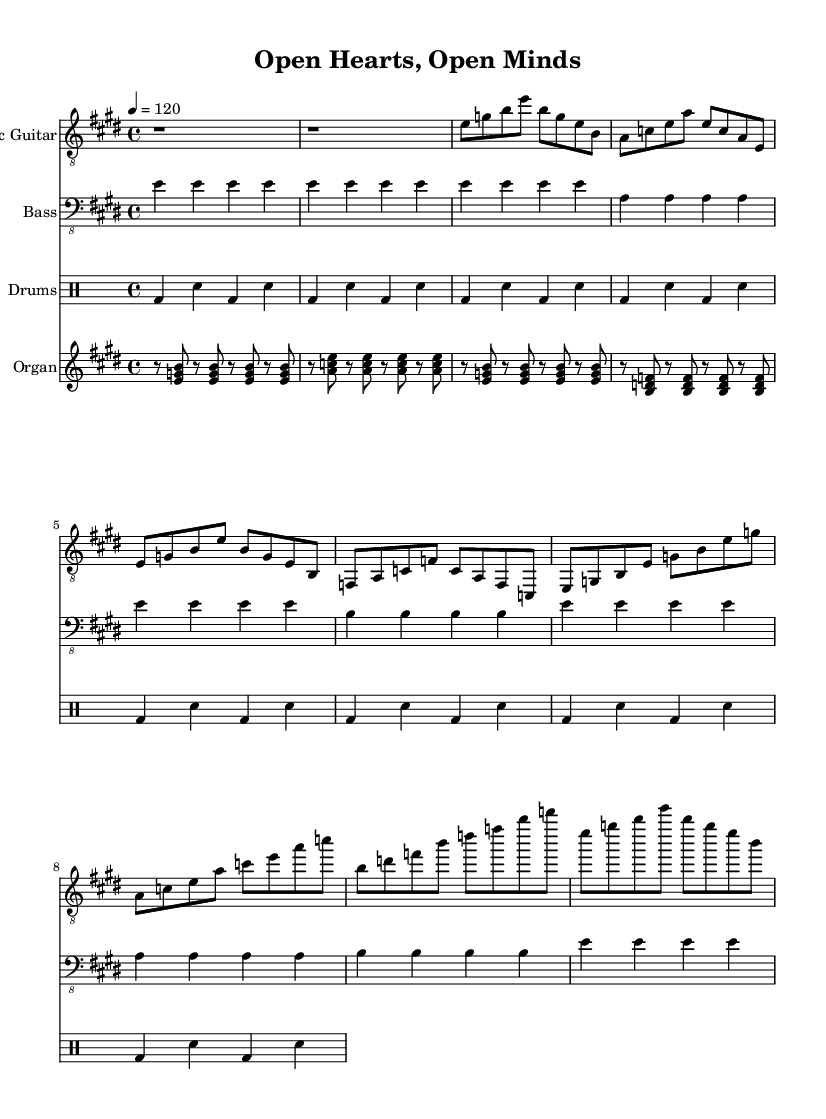What is the key signature of this piece? The key signature indicates the presence of four sharps, corresponding to E major.
Answer: E major What is the time signature of the music? The time signature shown in the music is 4/4, which means there are four beats in a measure and a quarter note gets one beat.
Answer: 4/4 What is the tempo marking for this composition? The tempo marking is indicated as "4 = 120," meaning there are 120 beats per minute, with each beat represented by a quarter note.
Answer: 120 How many measures are in the verse section? By analyzing the verse notation, there are four measures present. Each line of the verse consists of one measure, and there are four lines total.
Answer: 4 What type of instrument is providing the percussion part? The drumming part is clearly designated in a separate section labeled as "Drums," indicating that a drum kit is being used for the percussion.
Answer: Drums What distinctive feature does the organ part exhibit in terms of note placement? The organ part emphasizes offbeat chord stabs, which are consistently played on the eighth notes, creating a lively texture in the piece.
Answer: Offbeat chord stabs What musical genre does this piece belong to? The style of the music, characterized by its electric instrumentation and the overall structure, is identified as Electric Blues, a genre known for its expressiveness and improvisation.
Answer: Electric Blues 